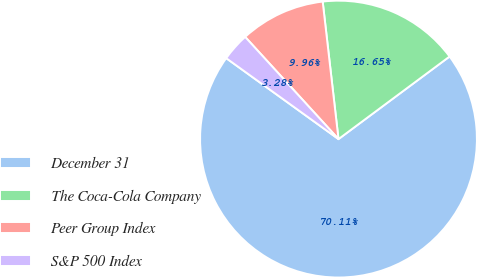Convert chart. <chart><loc_0><loc_0><loc_500><loc_500><pie_chart><fcel>December 31<fcel>The Coca-Cola Company<fcel>Peer Group Index<fcel>S&P 500 Index<nl><fcel>70.12%<fcel>16.65%<fcel>9.96%<fcel>3.28%<nl></chart> 